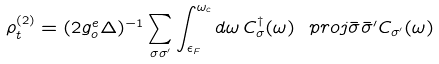<formula> <loc_0><loc_0><loc_500><loc_500>\rho ^ { ( 2 ) } _ { t } = ( 2 g _ { o } ^ { e } \Delta ) ^ { - 1 } \sum _ { \sigma \sigma ^ { \prime } } \int _ { \epsilon _ { F } } ^ { \omega _ { c } } d \omega \, C _ { \sigma } ^ { \dagger } ( \omega ) \ p r o j { \bar { \sigma } } { \bar { \sigma } ^ { \prime } } C _ { \sigma ^ { \prime } } ( \omega )</formula> 